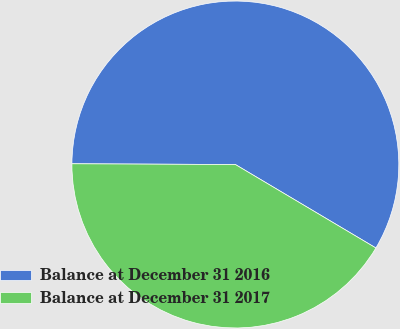<chart> <loc_0><loc_0><loc_500><loc_500><pie_chart><fcel>Balance at December 31 2016<fcel>Balance at December 31 2017<nl><fcel>58.46%<fcel>41.54%<nl></chart> 